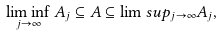Convert formula to latex. <formula><loc_0><loc_0><loc_500><loc_500>\liminf _ { j \to \infty } A _ { j } \subseteq A \subseteq \lim s u p _ { j \to \infty } A _ { j } ,</formula> 